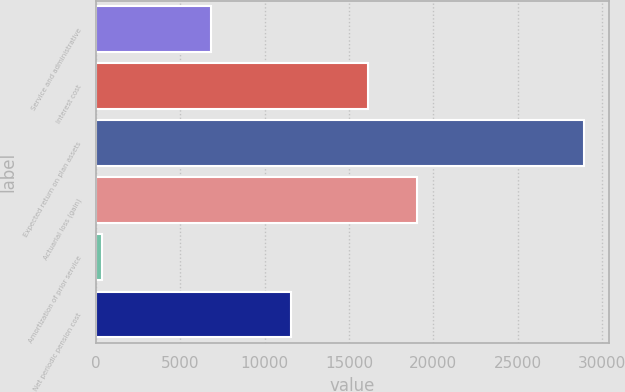Convert chart to OTSL. <chart><loc_0><loc_0><loc_500><loc_500><bar_chart><fcel>Service and administrative<fcel>Interest cost<fcel>Expected return on plan assets<fcel>Actuarial loss (gain)<fcel>Amortization of prior service<fcel>Net periodic pension cost<nl><fcel>6853<fcel>16146<fcel>28939<fcel>19002.4<fcel>375<fcel>11581<nl></chart> 